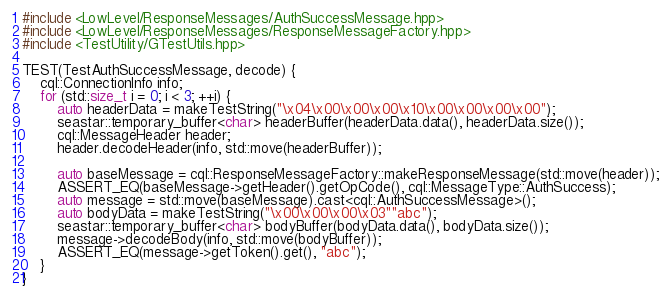Convert code to text. <code><loc_0><loc_0><loc_500><loc_500><_C++_>#include <LowLevel/ResponseMessages/AuthSuccessMessage.hpp>
#include <LowLevel/ResponseMessages/ResponseMessageFactory.hpp>
#include <TestUtility/GTestUtils.hpp>

TEST(TestAuthSuccessMessage, decode) {
	cql::ConnectionInfo info;
	for (std::size_t i = 0; i < 3; ++i) {
		auto headerData = makeTestString("\x04\x00\x00\x00\x10\x00\x00\x00\x00");
		seastar::temporary_buffer<char> headerBuffer(headerData.data(), headerData.size());
		cql::MessageHeader header;
		header.decodeHeader(info, std::move(headerBuffer));

		auto baseMessage = cql::ResponseMessageFactory::makeResponseMessage(std::move(header));
		ASSERT_EQ(baseMessage->getHeader().getOpCode(), cql::MessageType::AuthSuccess);
		auto message = std::move(baseMessage).cast<cql::AuthSuccessMessage>();
 		auto bodyData = makeTestString("\x00\x00\x00\x03""abc");
		seastar::temporary_buffer<char> bodyBuffer(bodyData.data(), bodyData.size());
		message->decodeBody(info, std::move(bodyBuffer));
		ASSERT_EQ(message->getToken().get(), "abc");
	}
}

</code> 